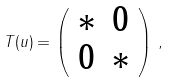<formula> <loc_0><loc_0><loc_500><loc_500>T ( u ) = \left ( \begin{array} { c c } * & 0 \\ 0 & * \end{array} \right ) \, ,</formula> 